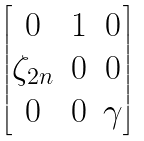<formula> <loc_0><loc_0><loc_500><loc_500>\begin{bmatrix} 0 & 1 & 0 \\ \zeta _ { 2 n } & 0 & 0 \\ 0 & 0 & \gamma \\ \end{bmatrix}</formula> 